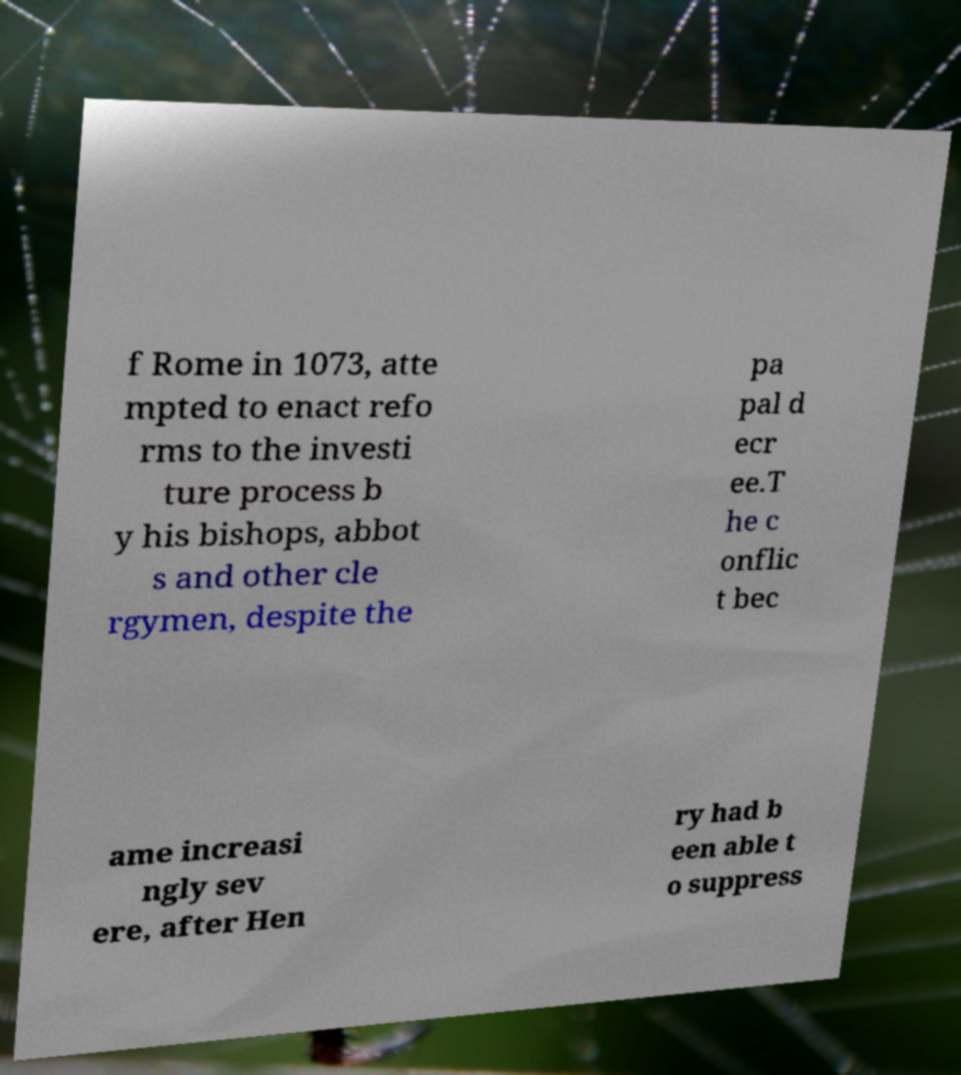Can you accurately transcribe the text from the provided image for me? f Rome in 1073, atte mpted to enact refo rms to the investi ture process b y his bishops, abbot s and other cle rgymen, despite the pa pal d ecr ee.T he c onflic t bec ame increasi ngly sev ere, after Hen ry had b een able t o suppress 